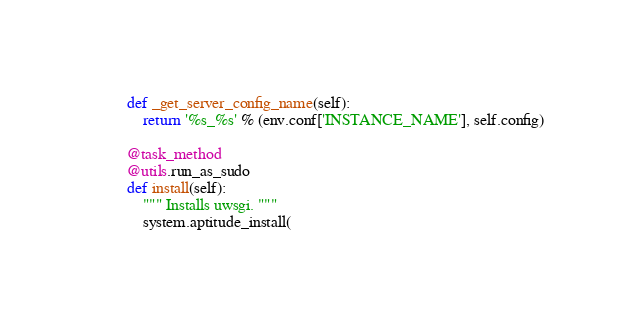<code> <loc_0><loc_0><loc_500><loc_500><_Python_>
    def _get_server_config_name(self):
        return '%s_%s' % (env.conf['INSTANCE_NAME'], self.config)

    @task_method
    @utils.run_as_sudo
    def install(self):
        """ Installs uwsgi. """
        system.aptitude_install(</code> 